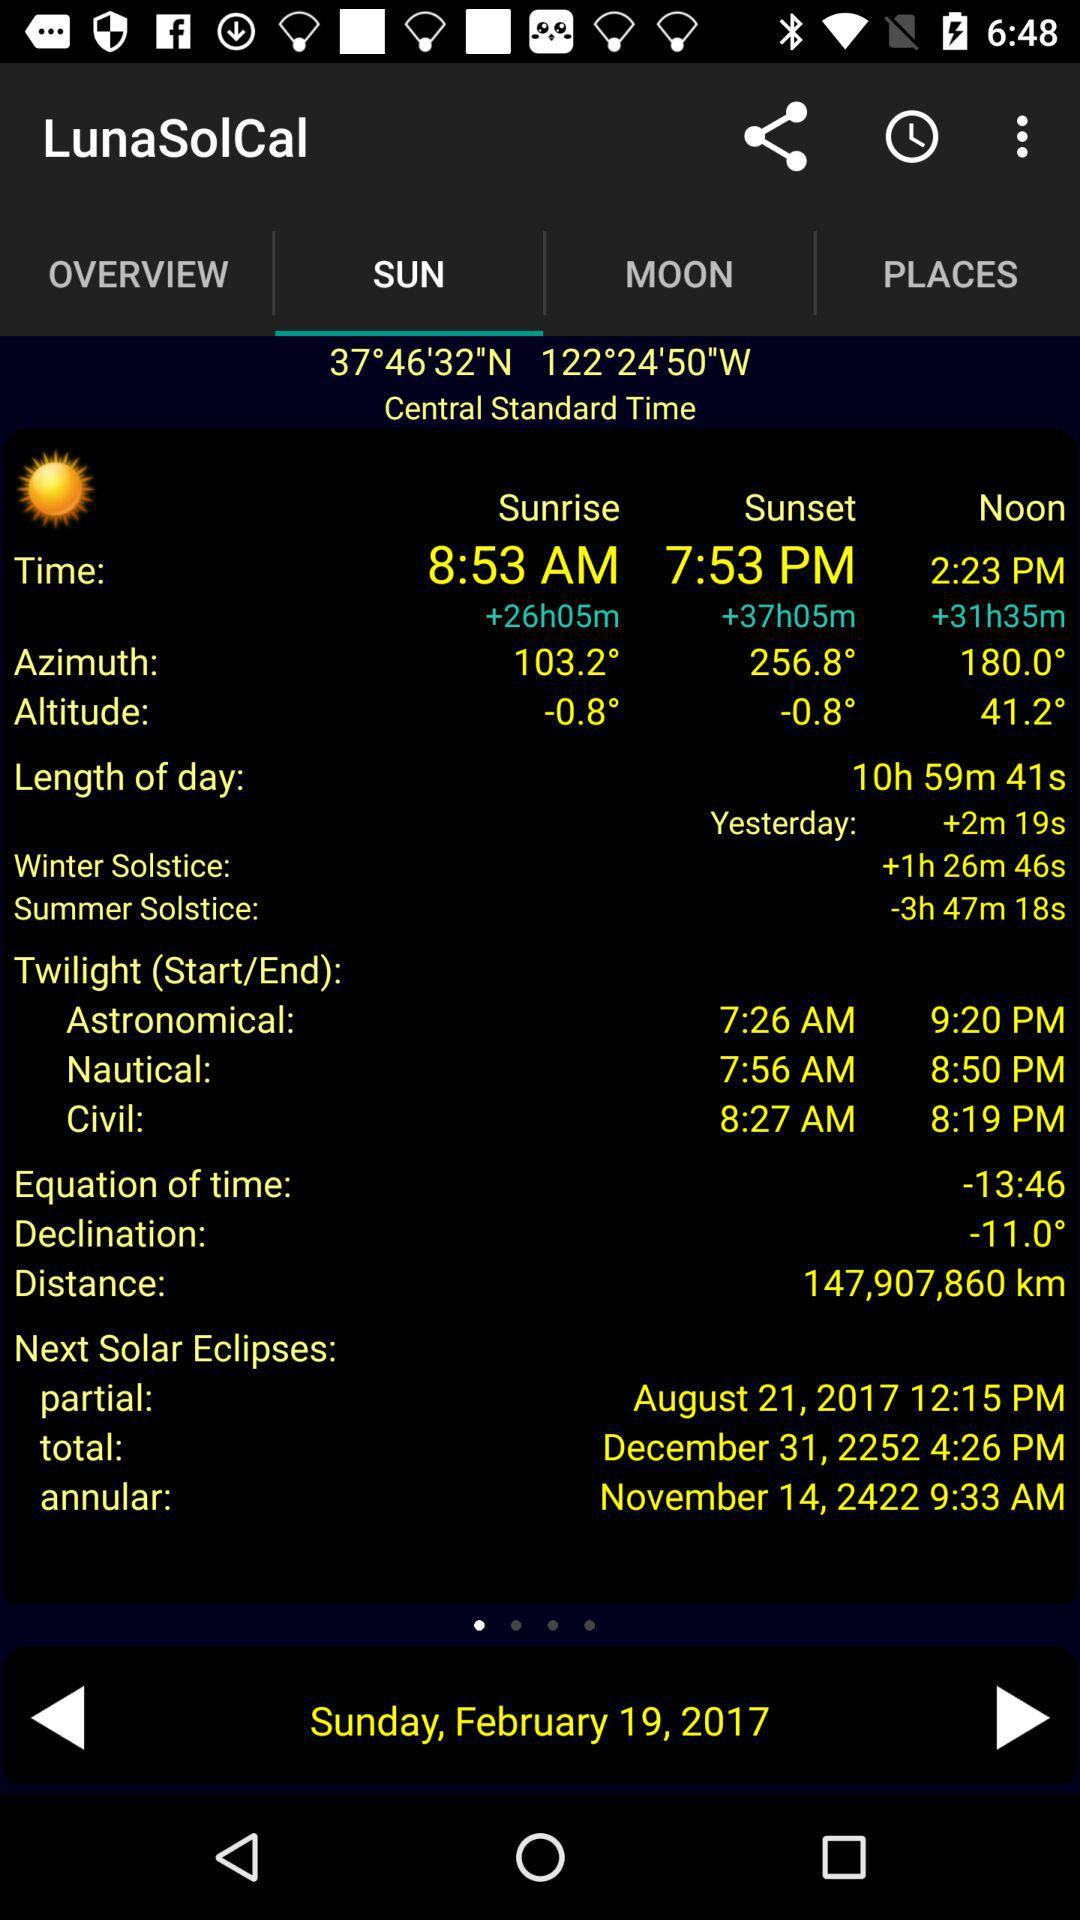The data is shown for what date? The date is Sunday, February 19, 2017. 